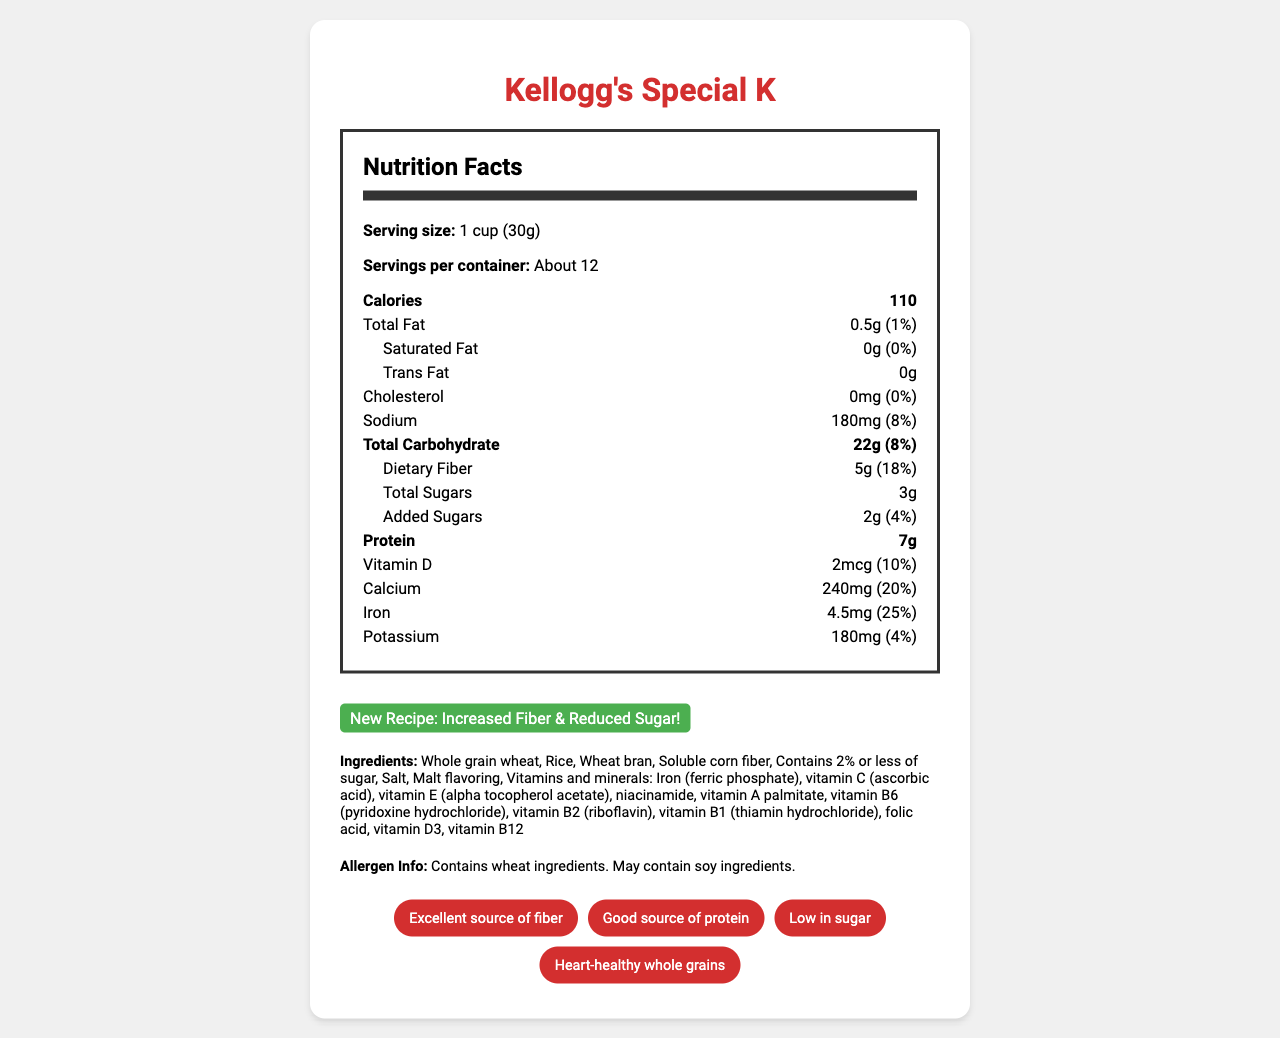what is the serving size for Kellogg's Special K? The serving size is clearly stated as "1 cup (30g)" in the nutrition label.
Answer: 1 cup (30g) how many calories are in one serving? The number of calories per serving is listed as 110 in the nutrition facts.
Answer: 110 what is the daily value percentage for dietary fiber? The daily value for dietary fiber is 18%, as indicated in the nutrition label.
Answer: 18% how much protein is in one serving of this cereal? The amount of protein per serving is listed as 7g in the nutrition facts.
Answer: 7g what are the primary colors used in the visual design? The primary color is #D32F2F, the secondary color is #FFFFFF, and the accent color is #4CAF50, as specified in the visual elements section.
Answer: #D32F2F (primary), #FFFFFF (secondary), #4CAF50 (accent) which ingredient is listed first in the ingredients list? The first ingredient listed in the ingredients section is "Whole grain wheat."
Answer: Whole grain wheat what vitamins and minerals are included in this cereal? The vitamins and minerals included are detailed in the ingredients list as "Iron (ferric phosphate), vitamin C (ascorbic acid), vitamin E (alpha tocopherol acetate), niacinamide, vitamin A palmitate, vitamin B6 (pyridoxine hydrochloride), vitamin B2 (riboflavin), vitamin B1 (thiamin hydrochloride), folic acid, vitamin D3, vitamin B12."
Answer: Iron, vitamin C, vitamin E, niacinamide, vitamin A, vitamin B6, vitamin B2, vitamin B1, folic acid, vitamin D3, vitamin B12 how much added sugars are in one serving? The amount of added sugars per serving is specifically noted as 2g in the nutrition facts.
Answer: 2g which of the following nutrients has the highest daily value percentage? A. Calcium B. Iron C. Vitamin D D. Dietary Fiber Calcium has a daily value percentage of 20%, Iron has 25%, Vitamin D has 10%, and Dietary Fiber has 18%. Hence, Iron has the highest daily value percentage.
Answer: B. Iron what is the color of the highlight used for "New Recipe: Increased Fiber & Reduced Sugar!" The highlight color for the "New Recipe" text is green, as specified in the color recommendations.
Answer: Green which claim is NOT made about this cereal? A. Excellent source of fiber B. Contains no artificial flavors C. Good source of protein D. Low in sugar The health claims listed are "Excellent source of fiber," "Good source of protein," "Low in sugar," and "Heart-healthy whole grains." There is no mention of "Contains no artificial flavors."
Answer: B is the sodium content in this cereal relatively high? The sodium content is 180mg, which is 8% of the daily value. This indicates it is not particularly high.
Answer: No summarize the main focus of the nutrition label and visual design. The document provides detailed nutritional information about Kellogg's Special K, featuring improved health benefits, such as increased fiber and reduced sugar. The visual design aids in highlighting these benefits, making the label more engaging and informative for consumers.
Answer: The redesigned Nutrition Facts Label for Kellogg's Special K emphasizes reduced sugar and increased fiber, portraying it as a healthier option. The label highlights the increase in fiber content and reduction in sugar with clear and bold text. Additionally, the visual design employs specific colors and icons to enhance readability and appeal, focusing on heart health and whole grains. how much soluble corn fiber is in each serving? The amount of soluble corn fiber per serving is not specified in the document; it is only listed as an ingredient.
Answer: Not enough information 